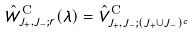Convert formula to latex. <formula><loc_0><loc_0><loc_500><loc_500>\hat { W } _ { J _ { + } , J _ { - } ; r } ^ { \text {C} } ( \lambda ) = \hat { V } _ { J _ { + } , J _ { - } ; ( J _ { + } \cup J _ { - } ) ^ { c } } ^ { \text {C} }</formula> 